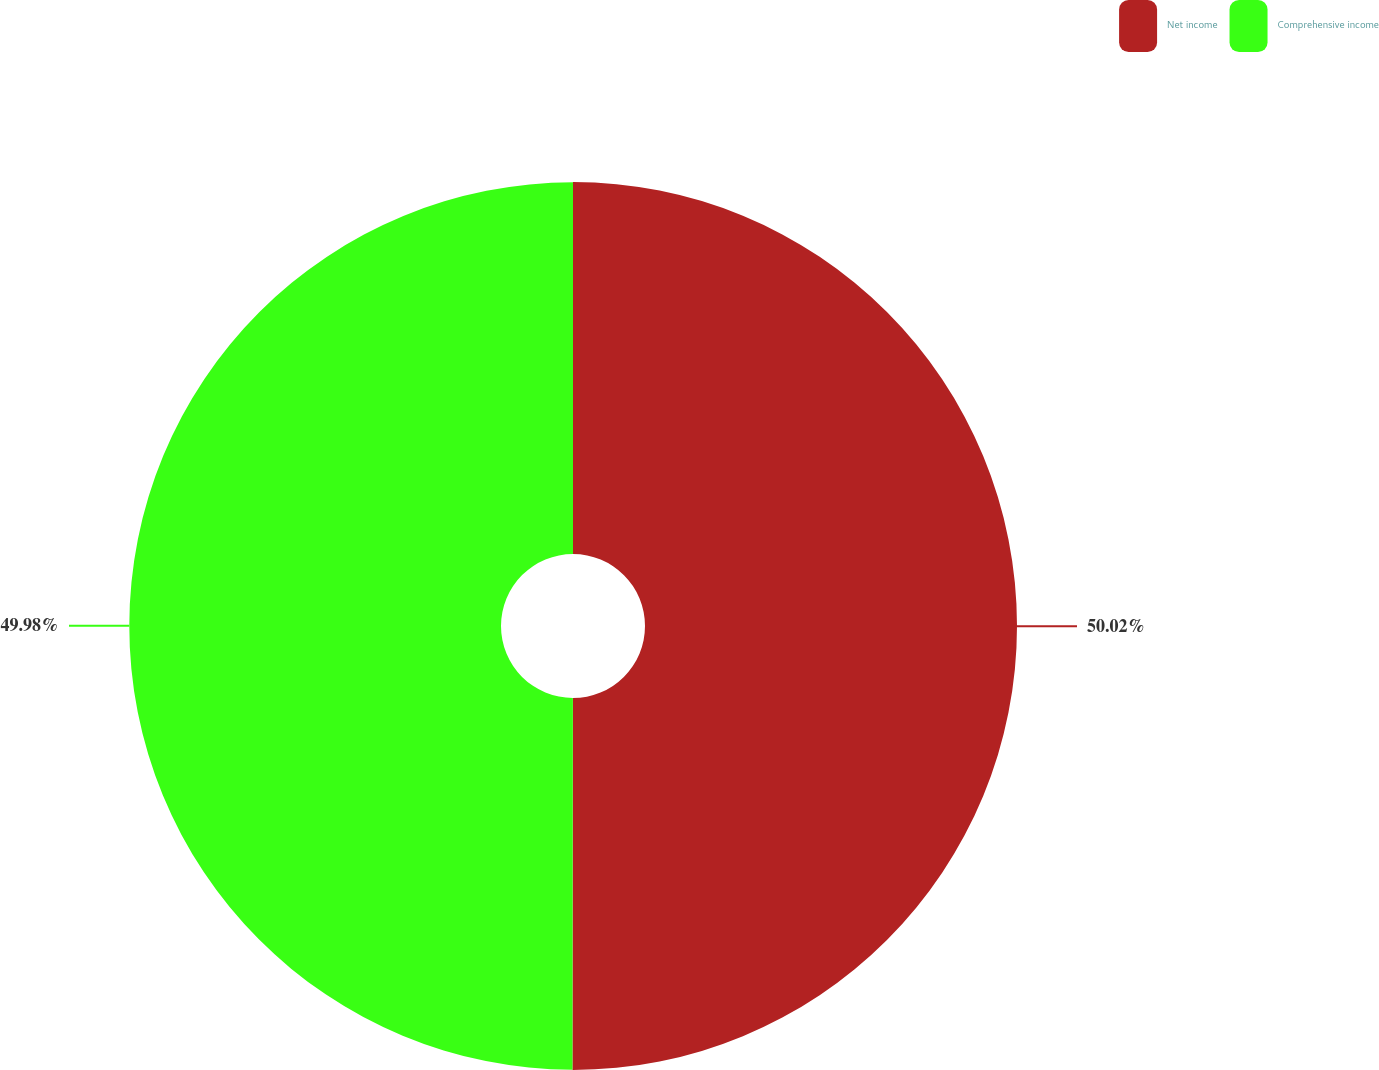<chart> <loc_0><loc_0><loc_500><loc_500><pie_chart><fcel>Net income<fcel>Comprehensive income<nl><fcel>50.02%<fcel>49.98%<nl></chart> 